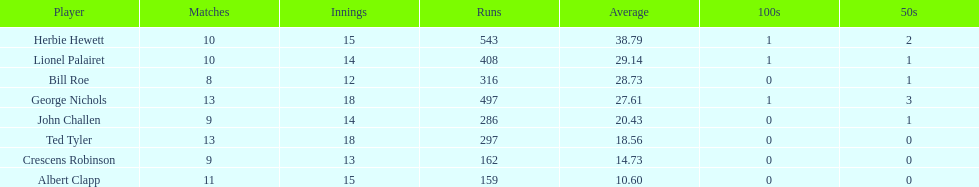What is the count of runs achieved by ted tyler? 297. 